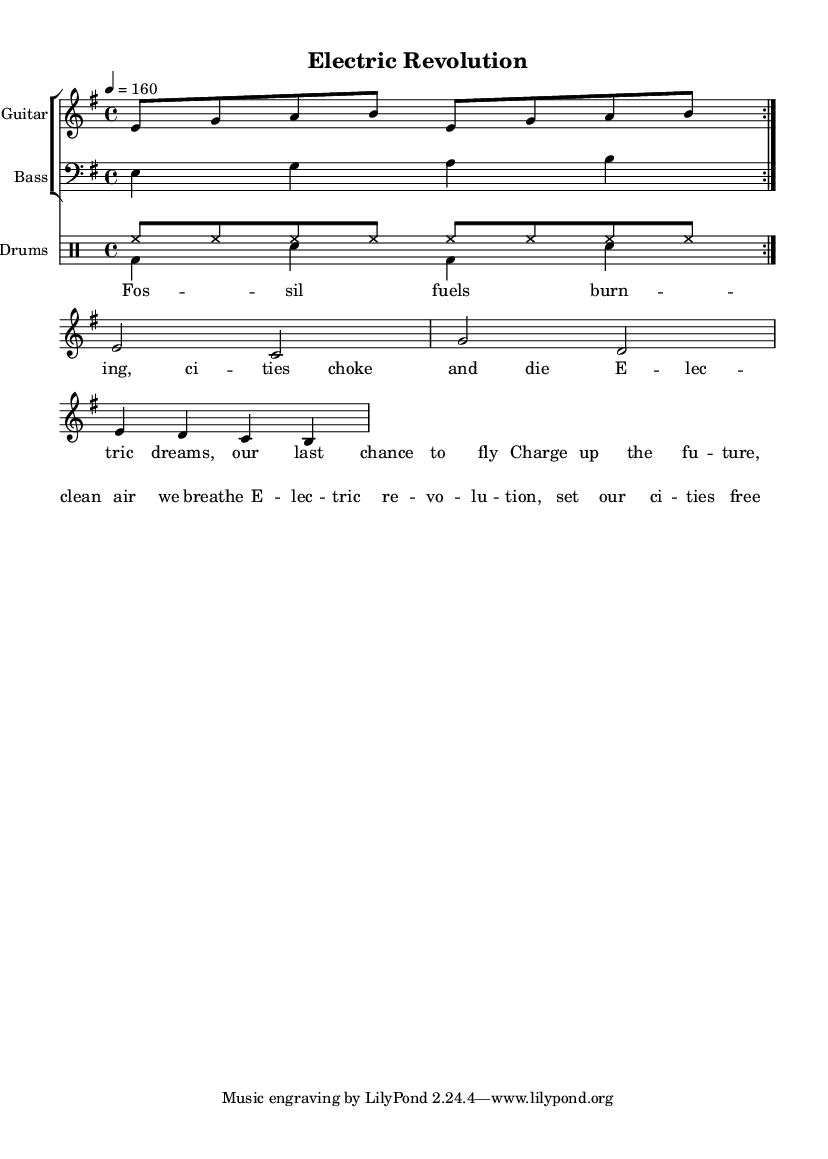What is the key signature of this music? The key signature is E minor, which contains one sharp (F#). The sheet music clearly indicates the key signature at the beginning of the staff lines.
Answer: E minor What is the time signature of the piece? The time signature is 4/4, which means there are four beats in each measure, and the quarter note gets one beat. This is evident from the time signature notation found at the beginning of the score.
Answer: 4/4 What is the tempo marking indicated in the music? The tempo marking is 4 = 160, which means there are 160 beats per minute, providing a fast and energetic pace typical for punk music. The tempo indication is displayed prominently in the score.
Answer: 160 How many measures are repeated in the guitar riff? The guitar riff is repeated twice, as indicated by the "repeat volta 2" marking following the guitar part. This marking signifies that the section before it should be played again.
Answer: 2 What is the main theme conveyed by the lyrics? The main theme is about advocating for an electric future and combating pollution. The lyrics explicitly talk about "Electric dreams" and "clean air," reflecting the song's focus on climate change.
Answer: Electric dreams, clean air What type of drum pattern is being used in the piece? The drum pattern consists of a combination of hi-hat strokes (hh) and various bass (bd) and snare (sn) hits, which are typical of punk rock's energetic drumming style. The pattern is distinctly marked in the drum notation.
Answer: Punk rock What emotion does the song likely convey based on the title and lyrics? The song likely conveys a sense of urgency and empowerment. The title "Electric Revolution" and the lyrics calling for change indicate a passionate plea for action against climate change. This emotional resonance is a common theme in punk music.
Answer: Urgency, empowerment 